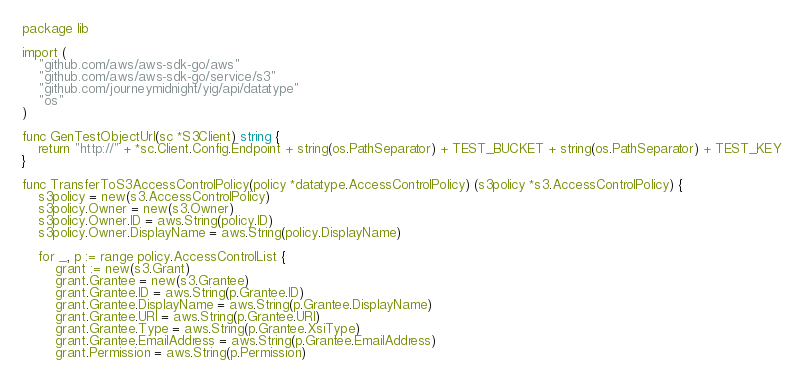Convert code to text. <code><loc_0><loc_0><loc_500><loc_500><_Go_>package lib

import (
	"github.com/aws/aws-sdk-go/aws"
	"github.com/aws/aws-sdk-go/service/s3"
	"github.com/journeymidnight/yig/api/datatype"
	"os"
)

func GenTestObjectUrl(sc *S3Client) string {
	return "http://" + *sc.Client.Config.Endpoint + string(os.PathSeparator) + TEST_BUCKET + string(os.PathSeparator) + TEST_KEY
}

func TransferToS3AccessControlPolicy(policy *datatype.AccessControlPolicy) (s3policy *s3.AccessControlPolicy) {
	s3policy = new(s3.AccessControlPolicy)
	s3policy.Owner = new(s3.Owner)
	s3policy.Owner.ID = aws.String(policy.ID)
	s3policy.Owner.DisplayName = aws.String(policy.DisplayName)

	for _, p := range policy.AccessControlList {
		grant := new(s3.Grant)
		grant.Grantee = new(s3.Grantee)
		grant.Grantee.ID = aws.String(p.Grantee.ID)
		grant.Grantee.DisplayName = aws.String(p.Grantee.DisplayName)
		grant.Grantee.URI = aws.String(p.Grantee.URI)
		grant.Grantee.Type = aws.String(p.Grantee.XsiType)
		grant.Grantee.EmailAddress = aws.String(p.Grantee.EmailAddress)
		grant.Permission = aws.String(p.Permission)</code> 